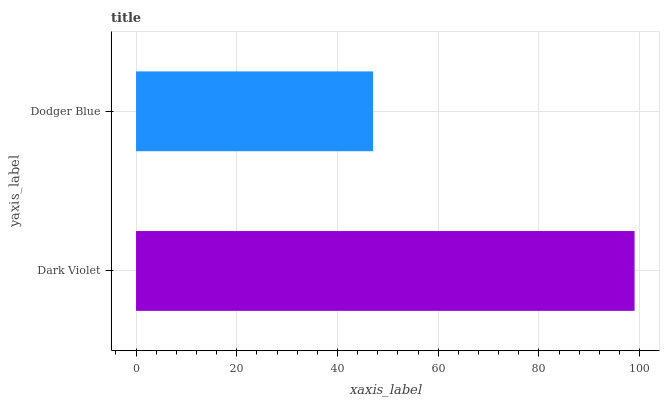Is Dodger Blue the minimum?
Answer yes or no. Yes. Is Dark Violet the maximum?
Answer yes or no. Yes. Is Dodger Blue the maximum?
Answer yes or no. No. Is Dark Violet greater than Dodger Blue?
Answer yes or no. Yes. Is Dodger Blue less than Dark Violet?
Answer yes or no. Yes. Is Dodger Blue greater than Dark Violet?
Answer yes or no. No. Is Dark Violet less than Dodger Blue?
Answer yes or no. No. Is Dark Violet the high median?
Answer yes or no. Yes. Is Dodger Blue the low median?
Answer yes or no. Yes. Is Dodger Blue the high median?
Answer yes or no. No. Is Dark Violet the low median?
Answer yes or no. No. 